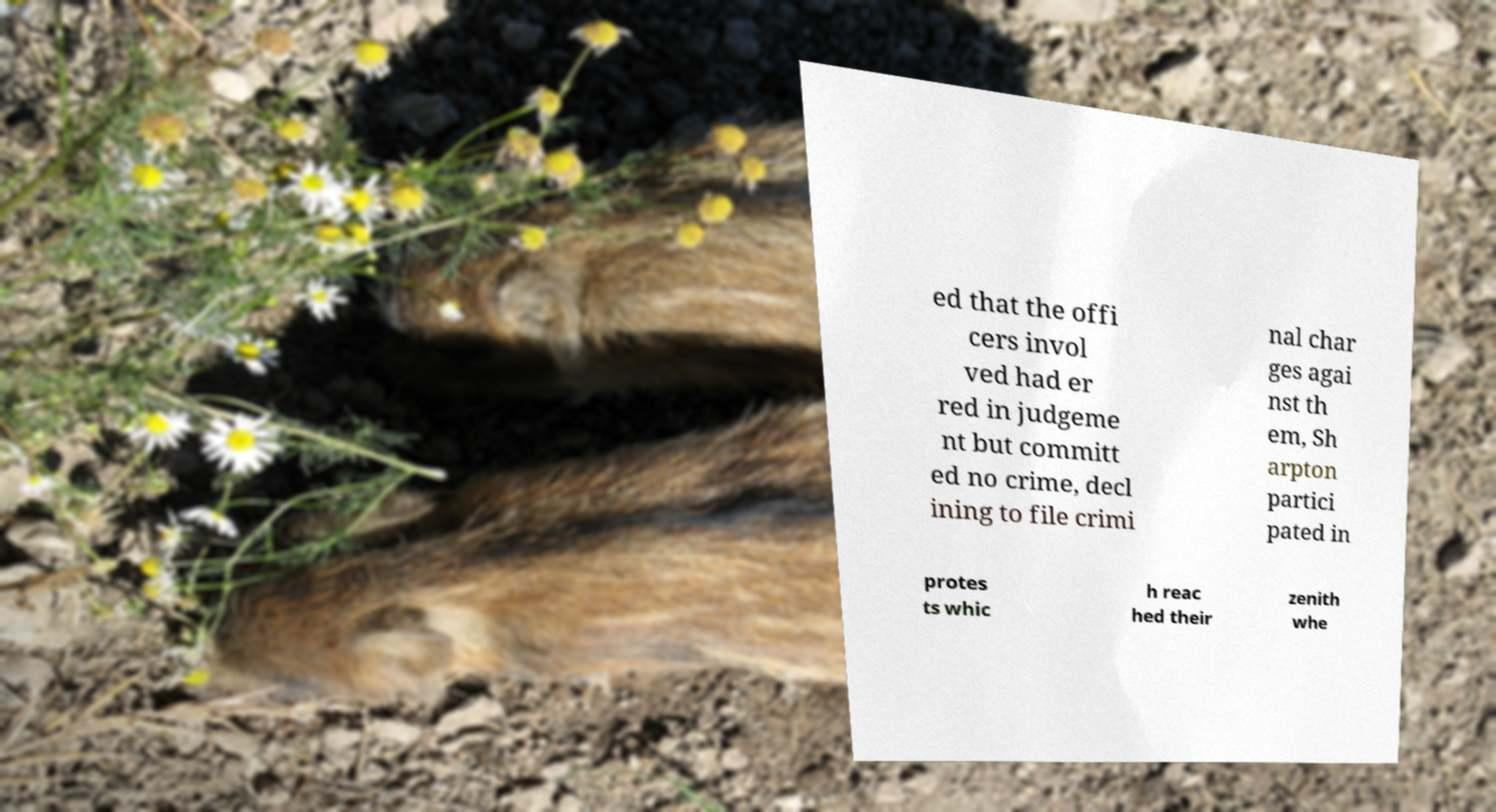I need the written content from this picture converted into text. Can you do that? ed that the offi cers invol ved had er red in judgeme nt but committ ed no crime, decl ining to file crimi nal char ges agai nst th em, Sh arpton partici pated in protes ts whic h reac hed their zenith whe 